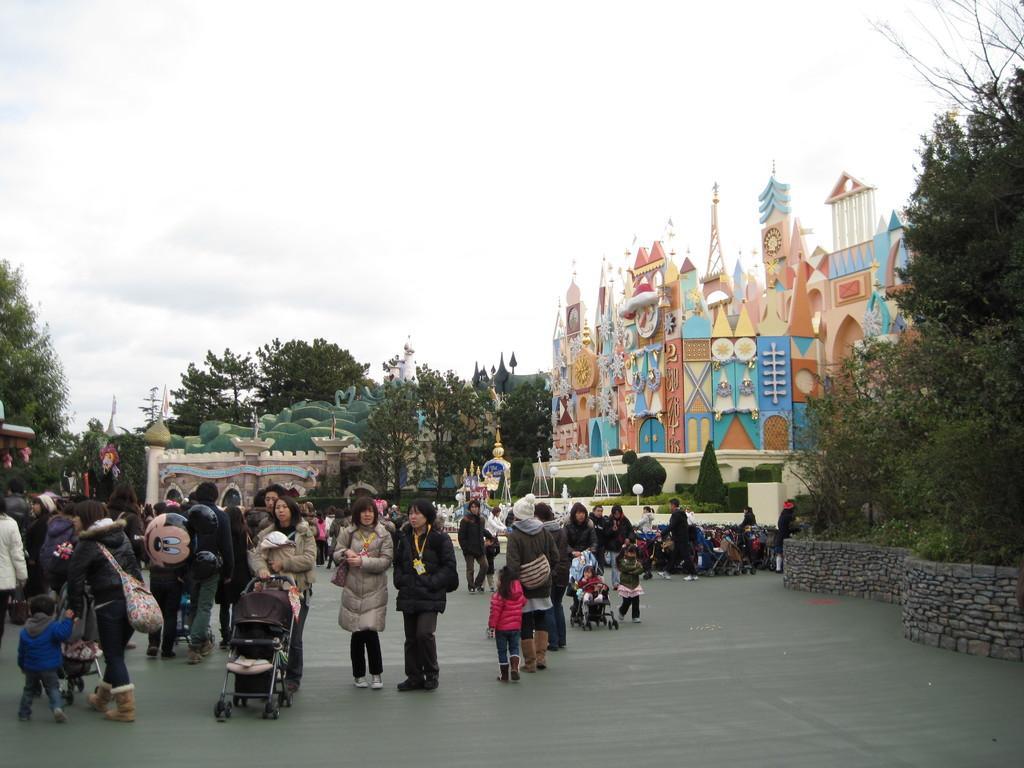Can you describe this image briefly? In this image we can see a group of people standing on the ground. One woman is wearing coat and holding a baby carrier with her hand. In the background, we can see a group of buildings, trees and the sky. 